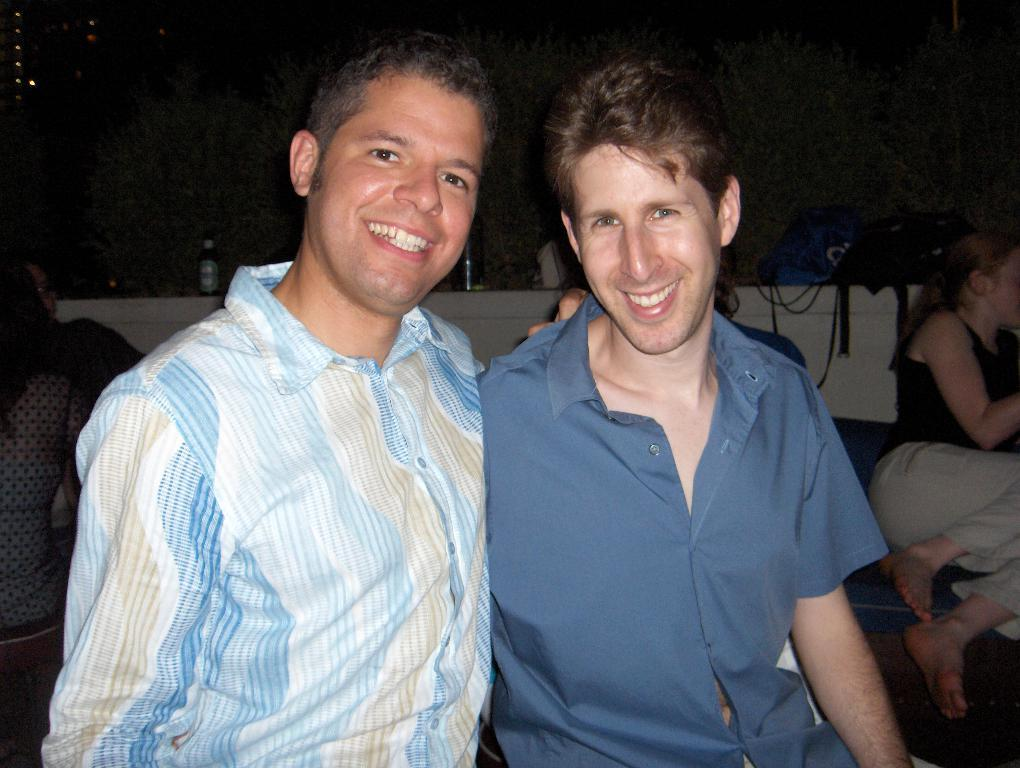How many people are in the image? There are three people in the image: two men and a woman. What are the men in the image doing? The men are smiling in the image. Where is the woman located in the image? The woman is on the right side of the image. What type of reaction does the jellyfish have to the men in the image? There is no jellyfish present in the image, so it cannot have any reaction to the men. 